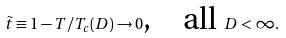<formula> <loc_0><loc_0><loc_500><loc_500>\tilde { t } \equiv 1 - T / T _ { c } ( D ) \rightarrow 0 \text {,\quad all } D < \infty .</formula> 